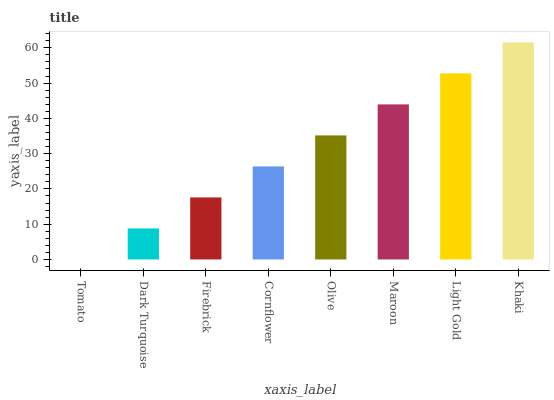Is Tomato the minimum?
Answer yes or no. Yes. Is Khaki the maximum?
Answer yes or no. Yes. Is Dark Turquoise the minimum?
Answer yes or no. No. Is Dark Turquoise the maximum?
Answer yes or no. No. Is Dark Turquoise greater than Tomato?
Answer yes or no. Yes. Is Tomato less than Dark Turquoise?
Answer yes or no. Yes. Is Tomato greater than Dark Turquoise?
Answer yes or no. No. Is Dark Turquoise less than Tomato?
Answer yes or no. No. Is Olive the high median?
Answer yes or no. Yes. Is Cornflower the low median?
Answer yes or no. Yes. Is Maroon the high median?
Answer yes or no. No. Is Light Gold the low median?
Answer yes or no. No. 